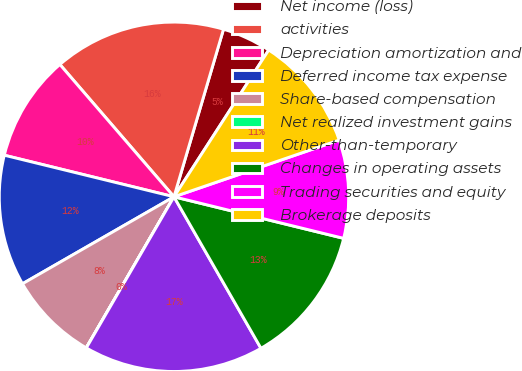<chart> <loc_0><loc_0><loc_500><loc_500><pie_chart><fcel>Net income (loss)<fcel>activities<fcel>Depreciation amortization and<fcel>Deferred income tax expense<fcel>Share-based compensation<fcel>Net realized investment gains<fcel>Other-than-temporary<fcel>Changes in operating assets<fcel>Trading securities and equity<fcel>Brokerage deposits<nl><fcel>4.55%<fcel>15.9%<fcel>9.85%<fcel>12.12%<fcel>8.33%<fcel>0.01%<fcel>16.66%<fcel>12.88%<fcel>9.09%<fcel>10.61%<nl></chart> 